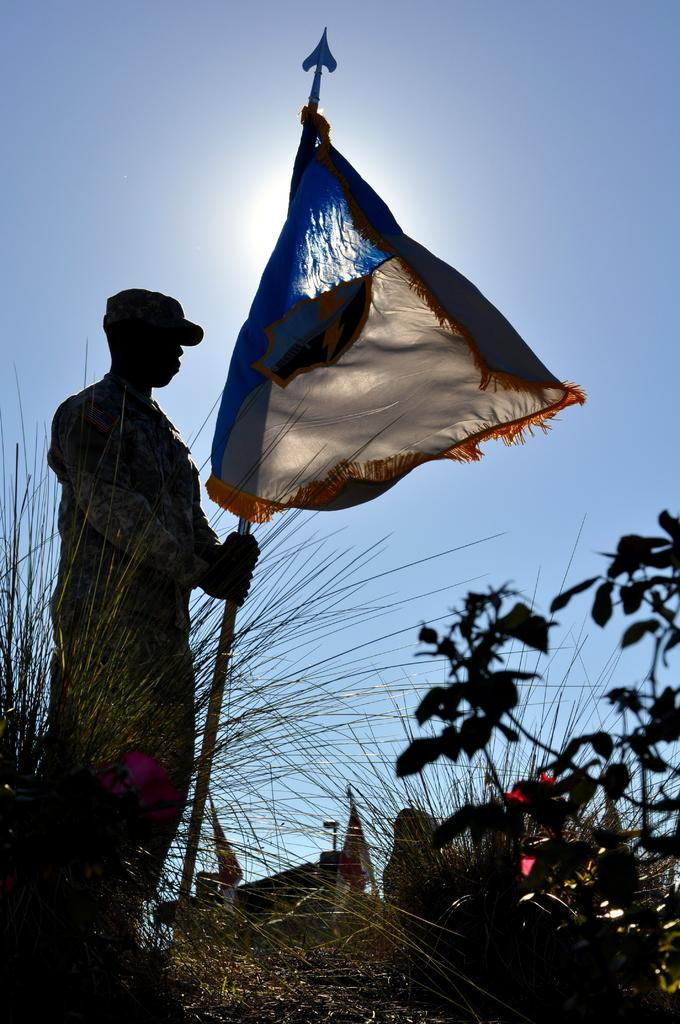What is the main subject of the image? There is a soldier in the image. What is the soldier doing in the image? The soldier is standing in the image. What is the soldier holding in the image? The soldier is holding a rod in the image. What is attached to the rod that the soldier is holding? A flag is attached to the rod. What can be seen beside the soldier in the image? There are plants beside the soldier in the image. What type of nail is the soldier using to hold the dress in the image? There is no nail or dress present in the image. How does the soldier's hearing affect their ability to perform their duties in the image? There is no information about the soldier's hearing in the image, so it cannot be determined how it affects their ability to perform their duties. 